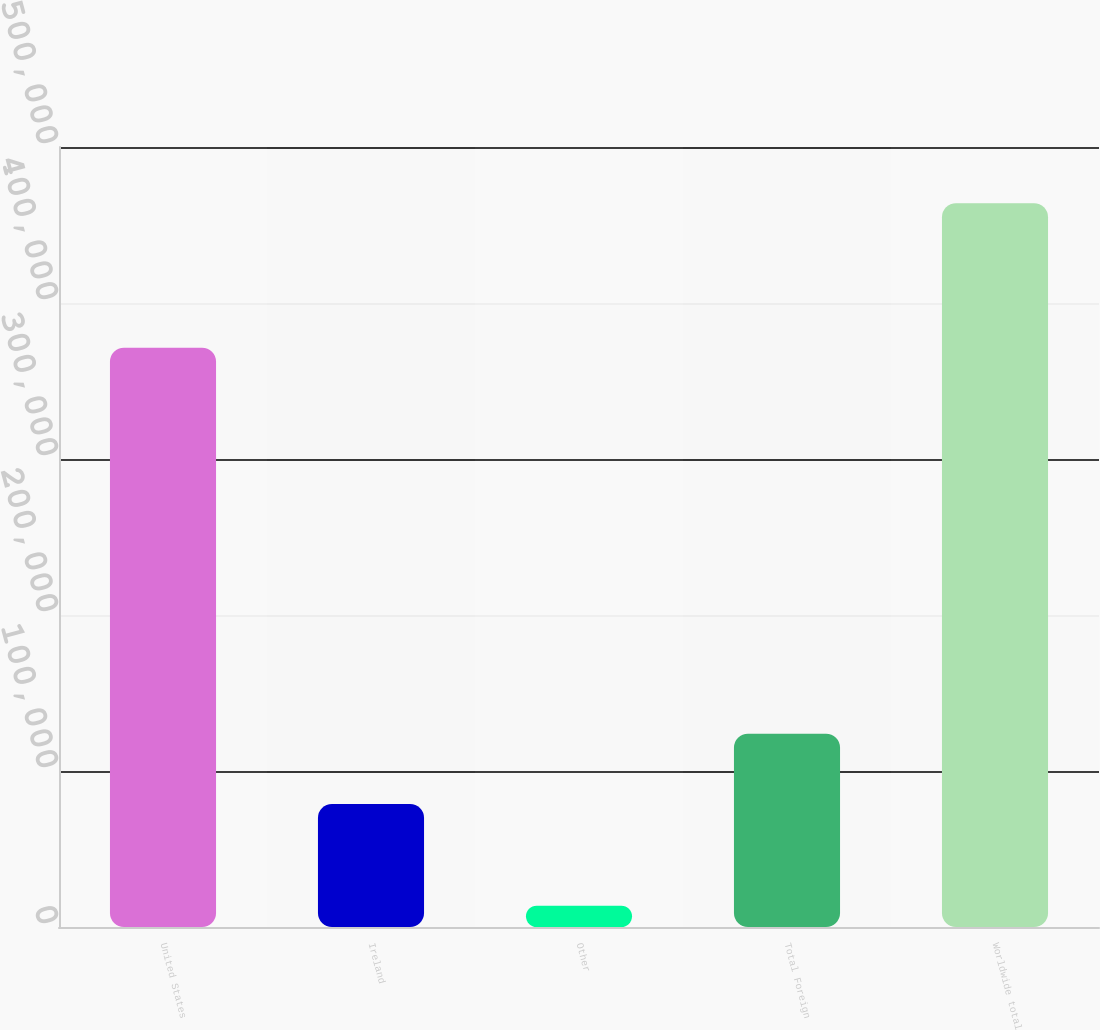Convert chart to OTSL. <chart><loc_0><loc_0><loc_500><loc_500><bar_chart><fcel>United States<fcel>Ireland<fcel>Other<fcel>Total Foreign<fcel>Worldwide total<nl><fcel>371380<fcel>78908<fcel>13643<fcel>123937<fcel>463931<nl></chart> 